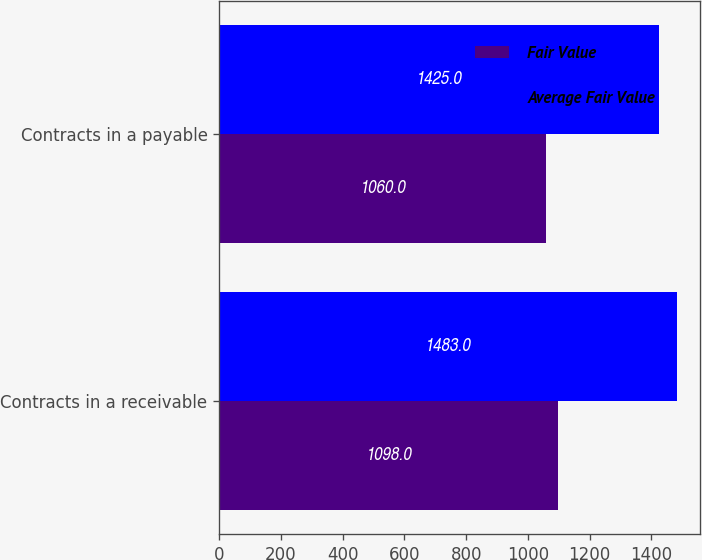Convert chart. <chart><loc_0><loc_0><loc_500><loc_500><stacked_bar_chart><ecel><fcel>Contracts in a receivable<fcel>Contracts in a payable<nl><fcel>Fair Value<fcel>1098<fcel>1060<nl><fcel>Average Fair Value<fcel>1483<fcel>1425<nl></chart> 